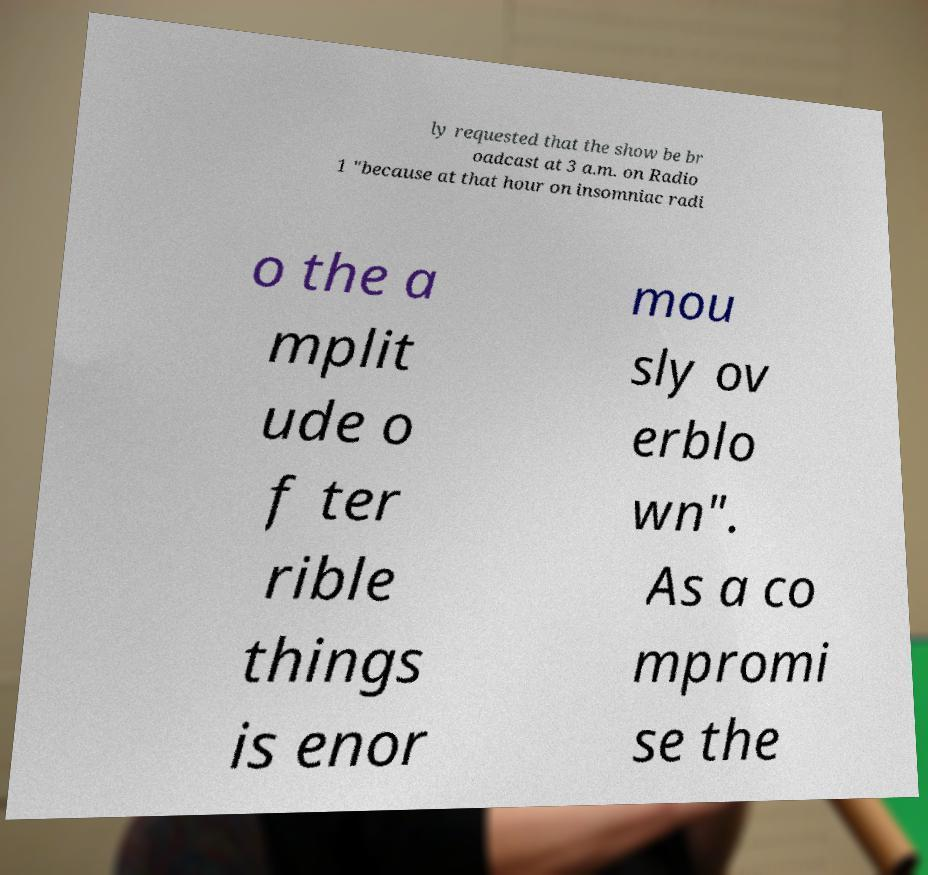Could you assist in decoding the text presented in this image and type it out clearly? ly requested that the show be br oadcast at 3 a.m. on Radio 1 "because at that hour on insomniac radi o the a mplit ude o f ter rible things is enor mou sly ov erblo wn". As a co mpromi se the 